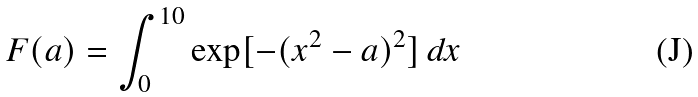Convert formula to latex. <formula><loc_0><loc_0><loc_500><loc_500>F ( a ) = \int ^ { 1 0 } _ { 0 } \text {exp} [ - ( x ^ { 2 } - a ) ^ { 2 } ] \, d x</formula> 